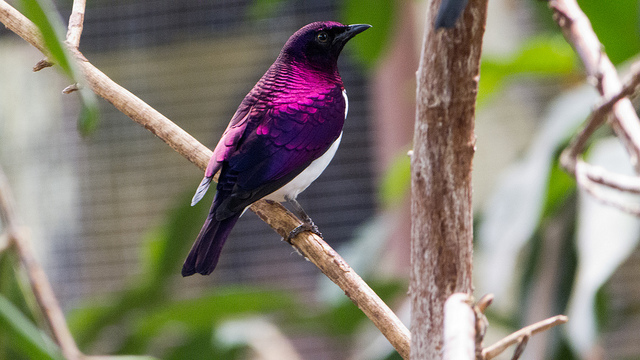Can you describe a typical day in the life of this bird? A typical day for an Amethyst Starling starts with the singing of the dawn chorus. As the sun rises, this bird leaves its perch to forage for food, often hunting for insects or seeking out berries and fruits. During the hottest part of the day, it may rest in the shade, preening its feathers and keeping cool. Social interactions are a key part of its day, as it communicates with other starlings using a variety of calls. As evening approaches, it returns to its roost to sleep, blending in seamlessly with the natural surroundings. 